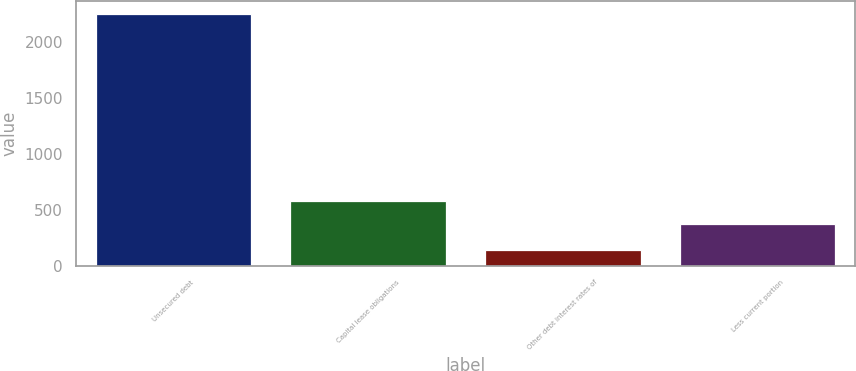Convert chart. <chart><loc_0><loc_0><loc_500><loc_500><bar_chart><fcel>Unsecured debt<fcel>Capital lease obligations<fcel>Other debt interest rates of<fcel>Less current portion<nl><fcel>2255<fcel>580.5<fcel>140<fcel>369<nl></chart> 